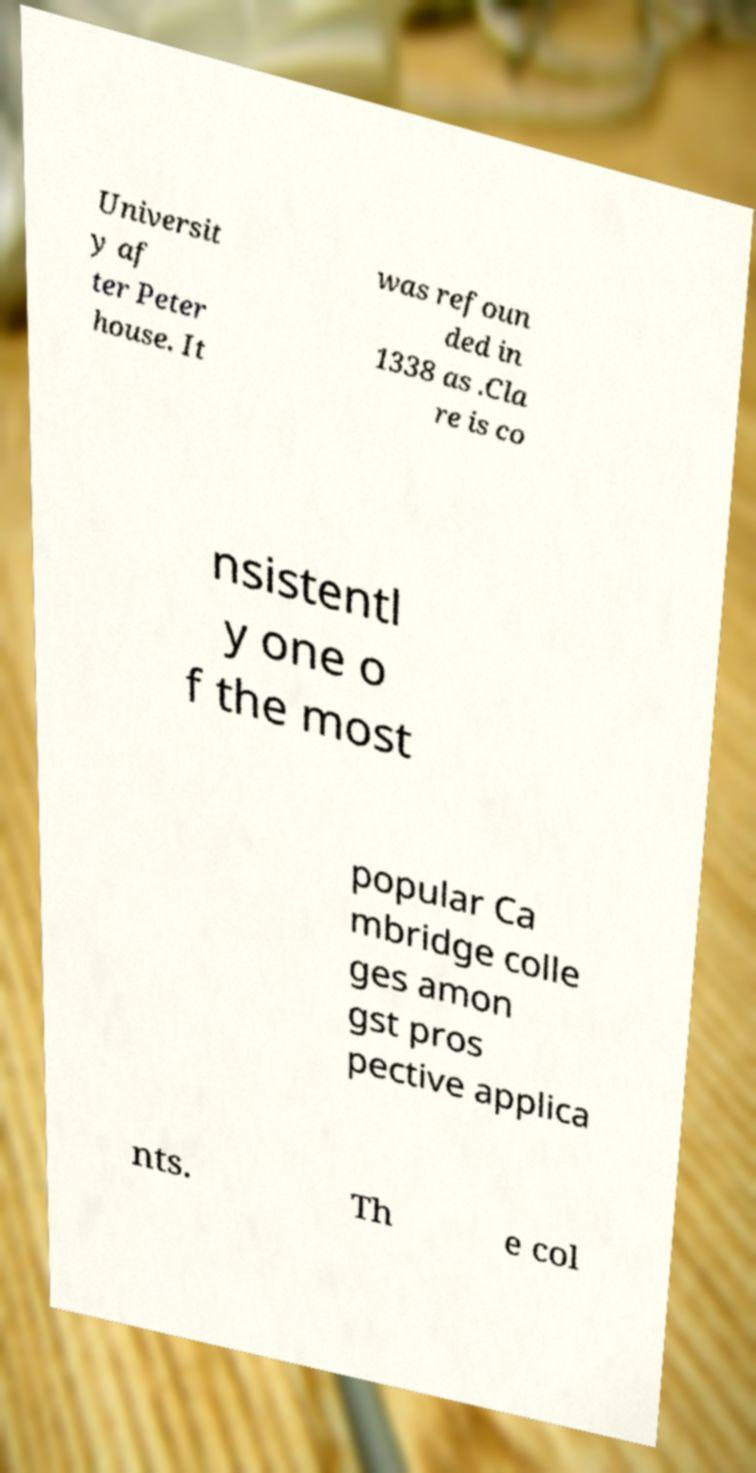For documentation purposes, I need the text within this image transcribed. Could you provide that? Universit y af ter Peter house. It was refoun ded in 1338 as .Cla re is co nsistentl y one o f the most popular Ca mbridge colle ges amon gst pros pective applica nts. Th e col 